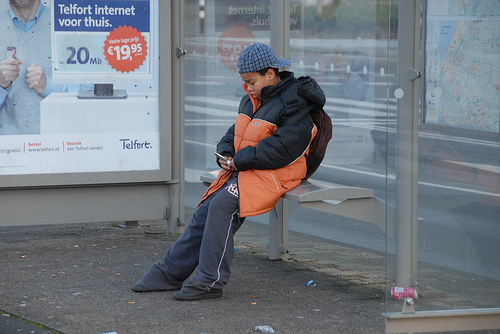Please transcribe the text in this image. 20 Telfort internet thuis. Voor 